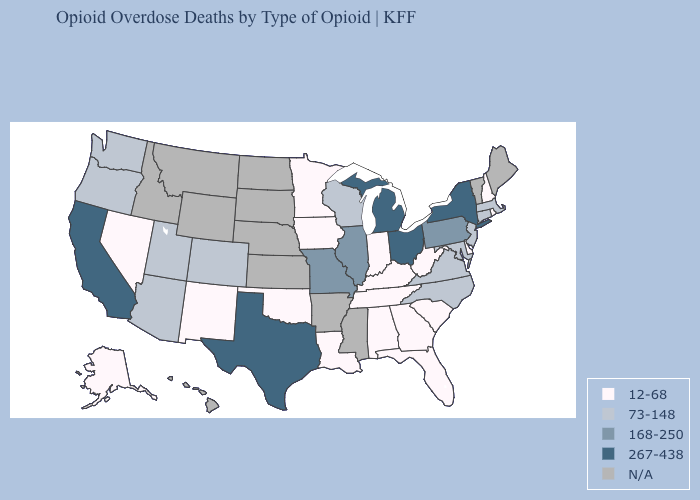Name the states that have a value in the range 168-250?
Give a very brief answer. Illinois, Missouri, Pennsylvania. Does New Mexico have the lowest value in the West?
Give a very brief answer. Yes. Does Missouri have the lowest value in the USA?
Quick response, please. No. Which states have the lowest value in the USA?
Write a very short answer. Alabama, Alaska, Delaware, Florida, Georgia, Indiana, Iowa, Kentucky, Louisiana, Minnesota, Nevada, New Hampshire, New Mexico, Oklahoma, Rhode Island, South Carolina, Tennessee, West Virginia. What is the value of Kentucky?
Quick response, please. 12-68. Name the states that have a value in the range 12-68?
Be succinct. Alabama, Alaska, Delaware, Florida, Georgia, Indiana, Iowa, Kentucky, Louisiana, Minnesota, Nevada, New Hampshire, New Mexico, Oklahoma, Rhode Island, South Carolina, Tennessee, West Virginia. What is the lowest value in states that border Indiana?
Concise answer only. 12-68. What is the value of Michigan?
Keep it brief. 267-438. Which states have the lowest value in the USA?
Answer briefly. Alabama, Alaska, Delaware, Florida, Georgia, Indiana, Iowa, Kentucky, Louisiana, Minnesota, Nevada, New Hampshire, New Mexico, Oklahoma, Rhode Island, South Carolina, Tennessee, West Virginia. Name the states that have a value in the range 73-148?
Answer briefly. Arizona, Colorado, Connecticut, Maryland, Massachusetts, New Jersey, North Carolina, Oregon, Utah, Virginia, Washington, Wisconsin. Which states have the highest value in the USA?
Answer briefly. California, Michigan, New York, Ohio, Texas. Does New Jersey have the highest value in the USA?
Quick response, please. No. What is the value of Arkansas?
Write a very short answer. N/A. Name the states that have a value in the range 267-438?
Be succinct. California, Michigan, New York, Ohio, Texas. 